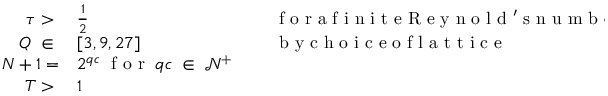Convert formula to latex. <formula><loc_0><loc_0><loc_500><loc_500>\begin{array} { r l r l } { \tau > \, } & \frac { 1 } { 2 } } & { \, } & f o r a f i n i t e R e y n o l d ^ { \prime } s n u m b e r } \\ { Q \, \in \, } & [ 3 , 9 , 2 7 ] } & { \, } & b y c h o i c e o f l a t t i c e } \\ { N + 1 = } & 2 ^ { q c } \, f o r \, q c \, \in \, \mathcal { N } ^ { + } } \\ { T > \, } & 1 } \end{array}</formula> 